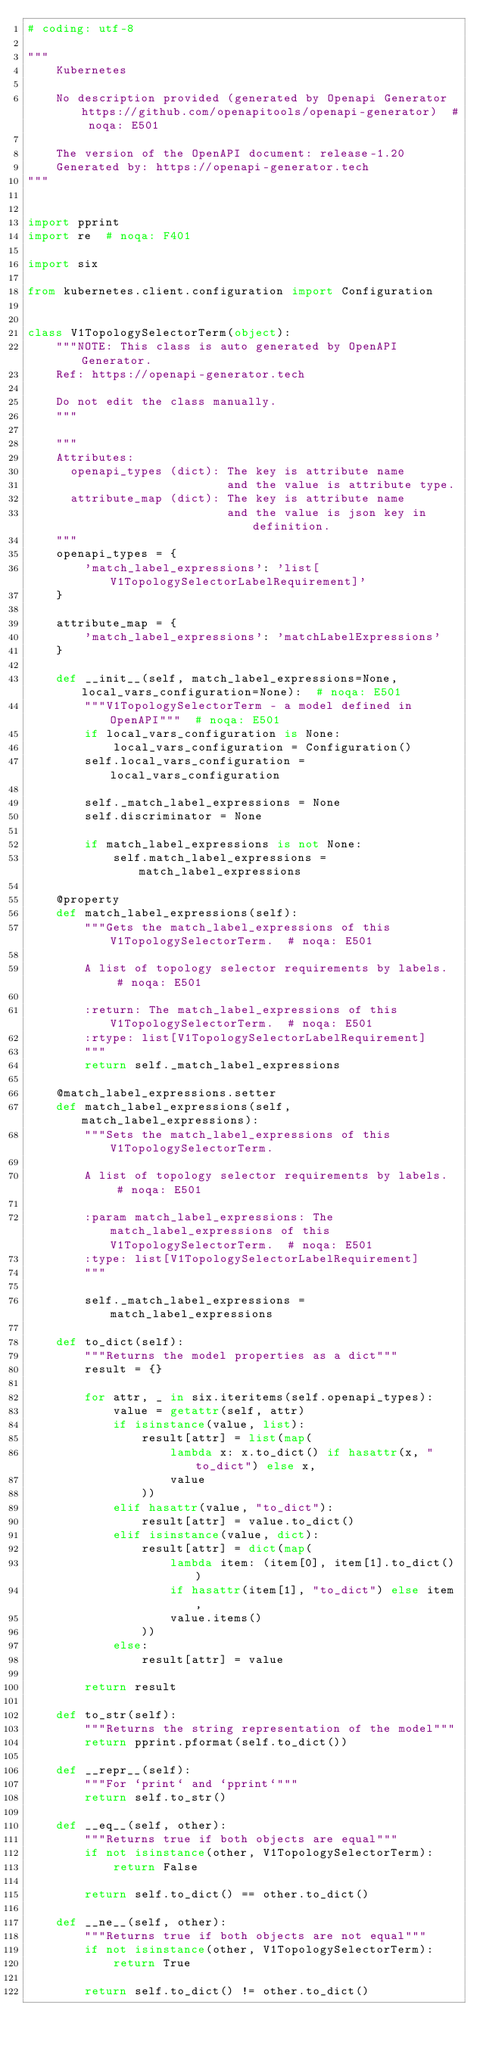<code> <loc_0><loc_0><loc_500><loc_500><_Python_># coding: utf-8

"""
    Kubernetes

    No description provided (generated by Openapi Generator https://github.com/openapitools/openapi-generator)  # noqa: E501

    The version of the OpenAPI document: release-1.20
    Generated by: https://openapi-generator.tech
"""


import pprint
import re  # noqa: F401

import six

from kubernetes.client.configuration import Configuration


class V1TopologySelectorTerm(object):
    """NOTE: This class is auto generated by OpenAPI Generator.
    Ref: https://openapi-generator.tech

    Do not edit the class manually.
    """

    """
    Attributes:
      openapi_types (dict): The key is attribute name
                            and the value is attribute type.
      attribute_map (dict): The key is attribute name
                            and the value is json key in definition.
    """
    openapi_types = {
        'match_label_expressions': 'list[V1TopologySelectorLabelRequirement]'
    }

    attribute_map = {
        'match_label_expressions': 'matchLabelExpressions'
    }

    def __init__(self, match_label_expressions=None, local_vars_configuration=None):  # noqa: E501
        """V1TopologySelectorTerm - a model defined in OpenAPI"""  # noqa: E501
        if local_vars_configuration is None:
            local_vars_configuration = Configuration()
        self.local_vars_configuration = local_vars_configuration

        self._match_label_expressions = None
        self.discriminator = None

        if match_label_expressions is not None:
            self.match_label_expressions = match_label_expressions

    @property
    def match_label_expressions(self):
        """Gets the match_label_expressions of this V1TopologySelectorTerm.  # noqa: E501

        A list of topology selector requirements by labels.  # noqa: E501

        :return: The match_label_expressions of this V1TopologySelectorTerm.  # noqa: E501
        :rtype: list[V1TopologySelectorLabelRequirement]
        """
        return self._match_label_expressions

    @match_label_expressions.setter
    def match_label_expressions(self, match_label_expressions):
        """Sets the match_label_expressions of this V1TopologySelectorTerm.

        A list of topology selector requirements by labels.  # noqa: E501

        :param match_label_expressions: The match_label_expressions of this V1TopologySelectorTerm.  # noqa: E501
        :type: list[V1TopologySelectorLabelRequirement]
        """

        self._match_label_expressions = match_label_expressions

    def to_dict(self):
        """Returns the model properties as a dict"""
        result = {}

        for attr, _ in six.iteritems(self.openapi_types):
            value = getattr(self, attr)
            if isinstance(value, list):
                result[attr] = list(map(
                    lambda x: x.to_dict() if hasattr(x, "to_dict") else x,
                    value
                ))
            elif hasattr(value, "to_dict"):
                result[attr] = value.to_dict()
            elif isinstance(value, dict):
                result[attr] = dict(map(
                    lambda item: (item[0], item[1].to_dict())
                    if hasattr(item[1], "to_dict") else item,
                    value.items()
                ))
            else:
                result[attr] = value

        return result

    def to_str(self):
        """Returns the string representation of the model"""
        return pprint.pformat(self.to_dict())

    def __repr__(self):
        """For `print` and `pprint`"""
        return self.to_str()

    def __eq__(self, other):
        """Returns true if both objects are equal"""
        if not isinstance(other, V1TopologySelectorTerm):
            return False

        return self.to_dict() == other.to_dict()

    def __ne__(self, other):
        """Returns true if both objects are not equal"""
        if not isinstance(other, V1TopologySelectorTerm):
            return True

        return self.to_dict() != other.to_dict()
</code> 